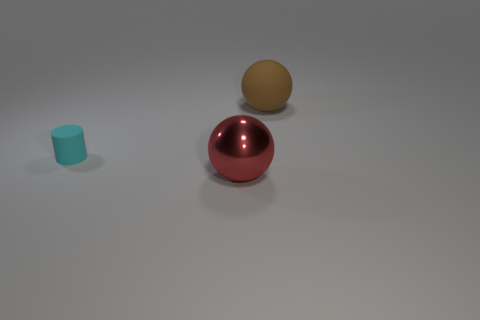Add 2 red metallic cubes. How many objects exist? 5 Subtract all spheres. How many objects are left? 1 Subtract 0 gray balls. How many objects are left? 3 Subtract all big brown matte cylinders. Subtract all brown matte things. How many objects are left? 2 Add 2 small cyan things. How many small cyan things are left? 3 Add 3 tiny gray shiny cubes. How many tiny gray shiny cubes exist? 3 